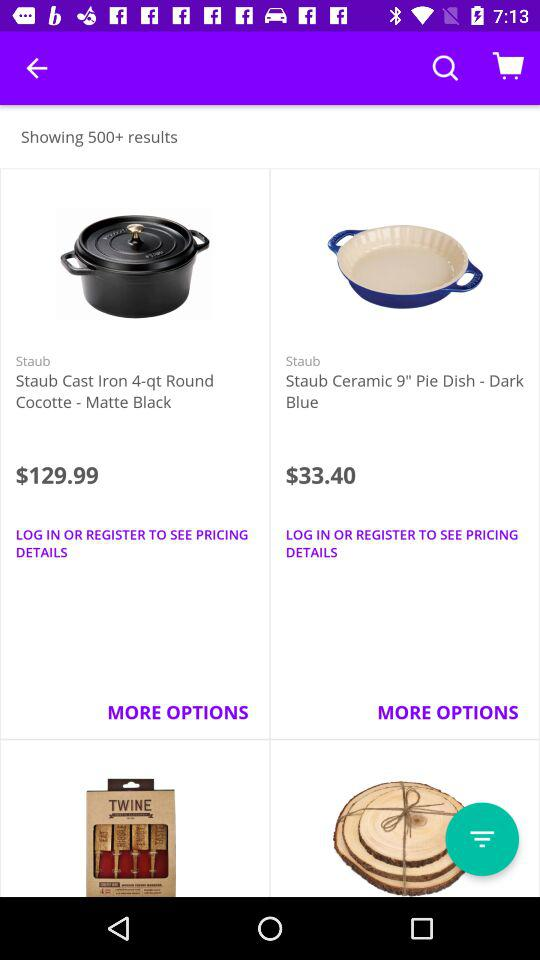What's the price of "Staub Cast Iron 4-qt Round Cocotte - Matte Black"? The price of "Staub Cast Iron 4-qt Round Cocotte - Matte Black" is $129.99. 